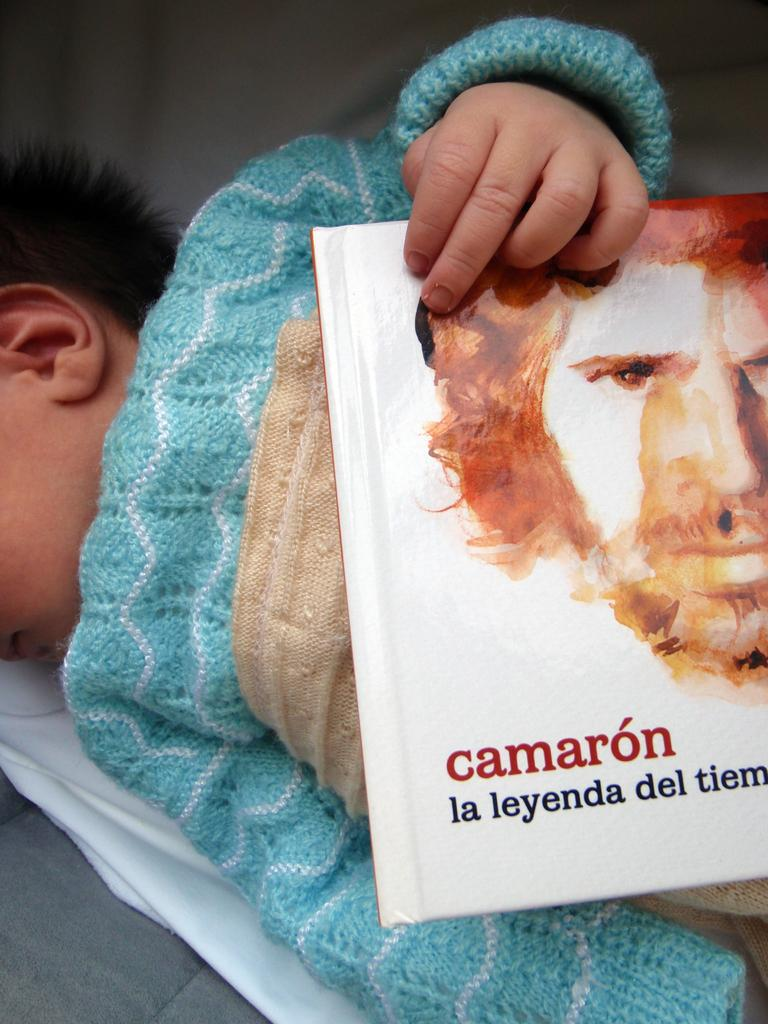What is the main subject of the image? There is a baby in the image. What is the baby doing in the image? The baby is lying down. What object is the baby holding in their hands? The baby is holding a book in their hands. What type of division is taking place at the seashore in the image? There is no seashore or division present in the image; it features a baby lying down and holding a book. How does the baby's son contribute to the scene in the image? There is no son present in the image, as the main subject is a baby. 